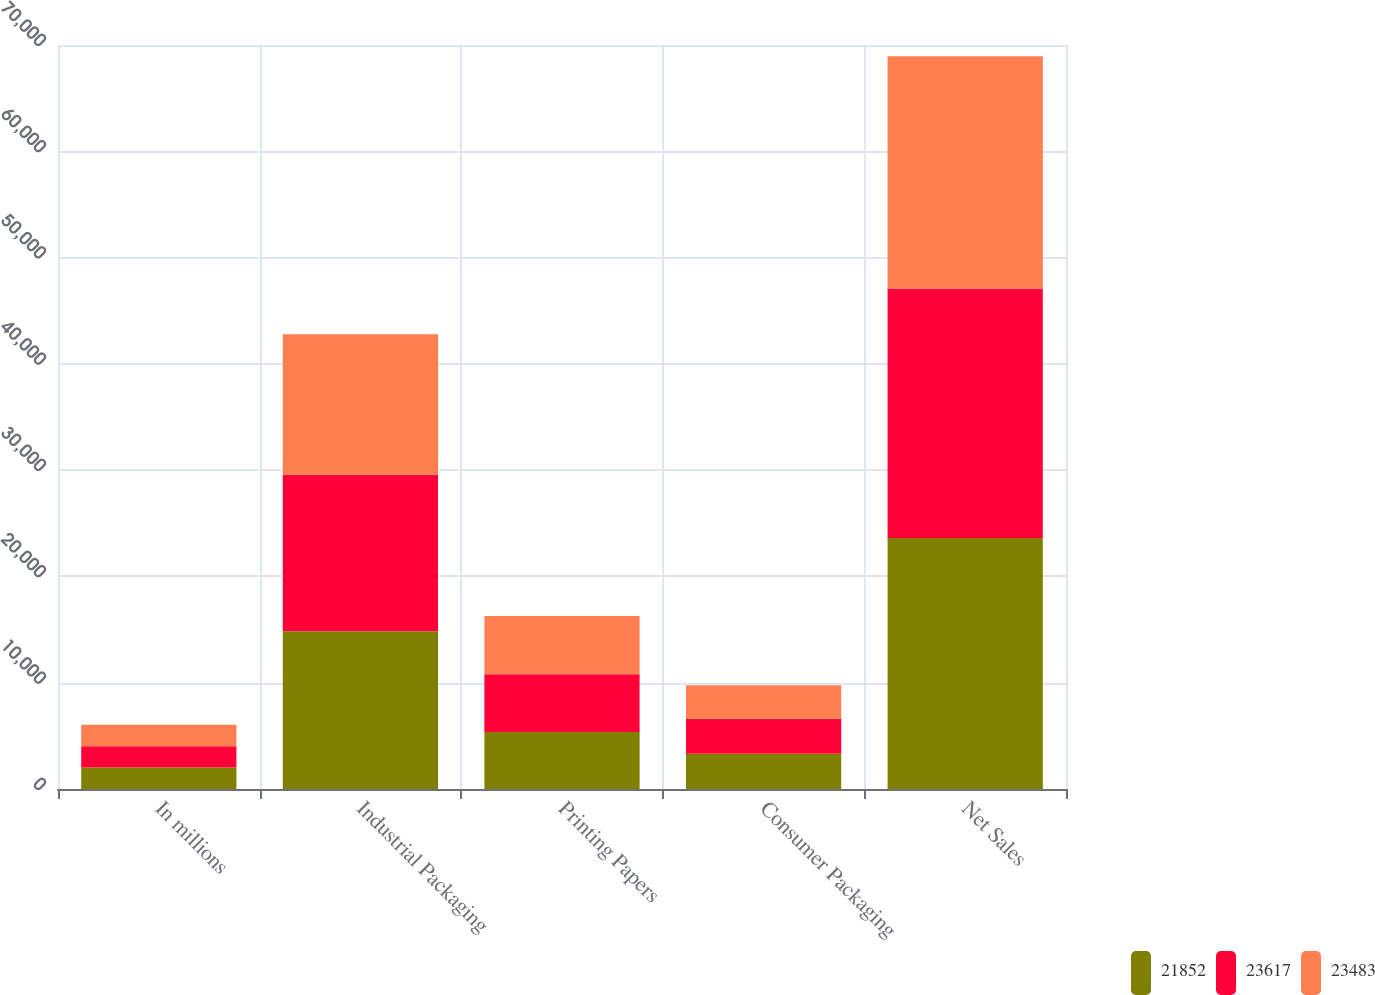<chart> <loc_0><loc_0><loc_500><loc_500><stacked_bar_chart><ecel><fcel>In millions<fcel>Industrial Packaging<fcel>Printing Papers<fcel>Consumer Packaging<fcel>Net Sales<nl><fcel>21852<fcel>2014<fcel>14837<fcel>5360<fcel>3307<fcel>23617<nl><fcel>23617<fcel>2013<fcel>14729<fcel>5443<fcel>3311<fcel>23483<nl><fcel>23483<fcel>2012<fcel>13223<fcel>5483<fcel>3146<fcel>21852<nl></chart> 